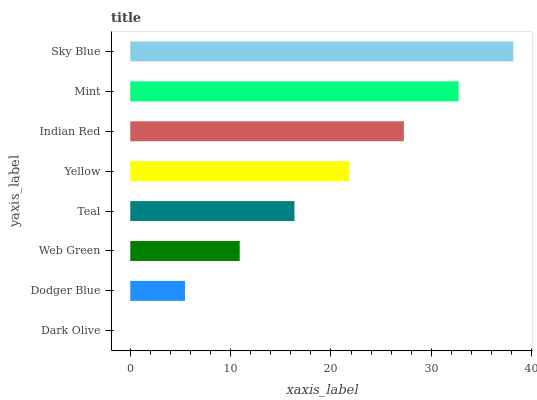Is Dark Olive the minimum?
Answer yes or no. Yes. Is Sky Blue the maximum?
Answer yes or no. Yes. Is Dodger Blue the minimum?
Answer yes or no. No. Is Dodger Blue the maximum?
Answer yes or no. No. Is Dodger Blue greater than Dark Olive?
Answer yes or no. Yes. Is Dark Olive less than Dodger Blue?
Answer yes or no. Yes. Is Dark Olive greater than Dodger Blue?
Answer yes or no. No. Is Dodger Blue less than Dark Olive?
Answer yes or no. No. Is Yellow the high median?
Answer yes or no. Yes. Is Teal the low median?
Answer yes or no. Yes. Is Sky Blue the high median?
Answer yes or no. No. Is Sky Blue the low median?
Answer yes or no. No. 